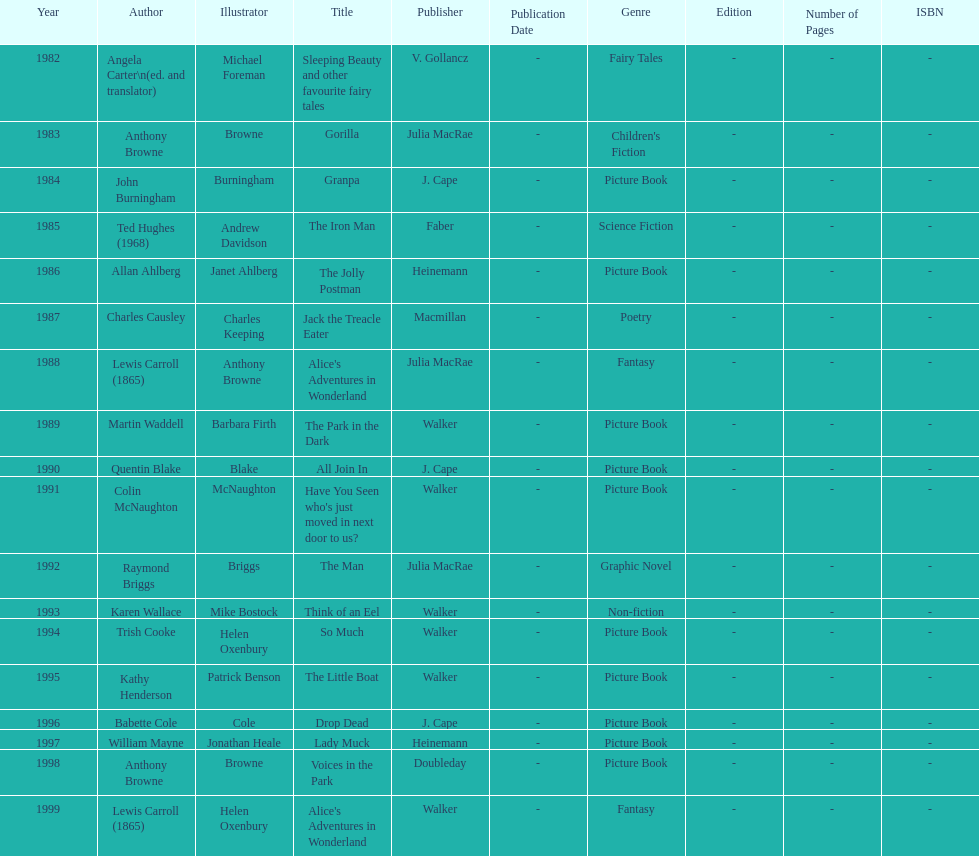How many titles had the same author listed as the illustrator? 7. 